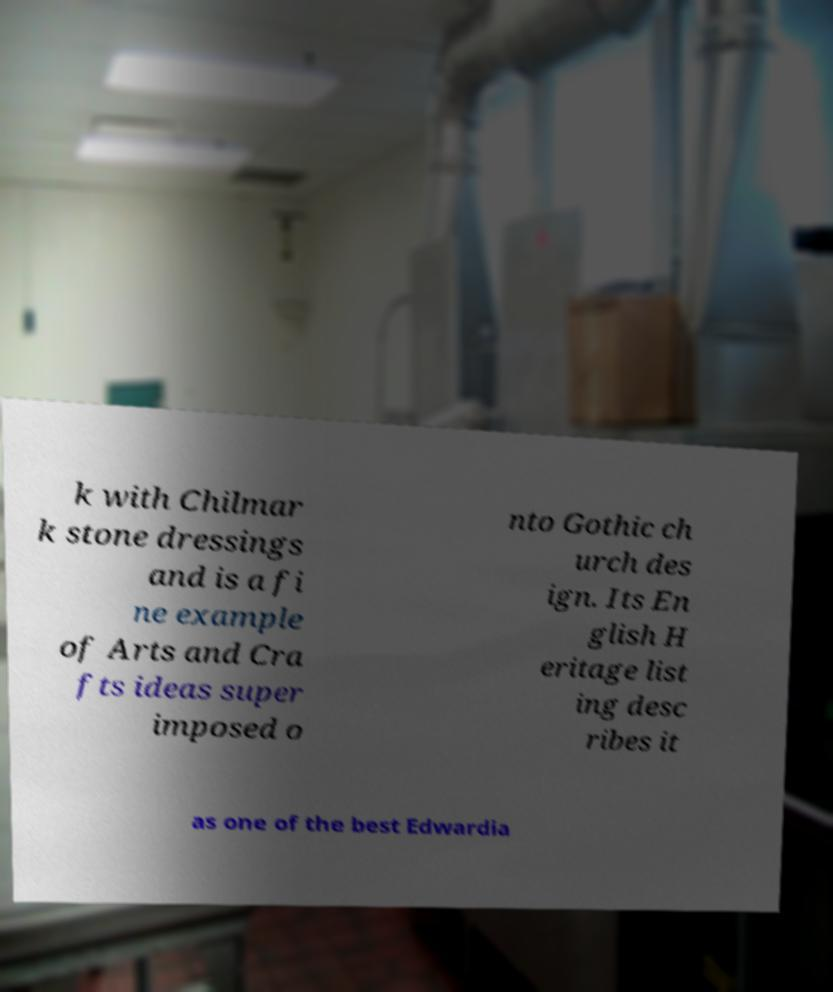Can you read and provide the text displayed in the image?This photo seems to have some interesting text. Can you extract and type it out for me? k with Chilmar k stone dressings and is a fi ne example of Arts and Cra fts ideas super imposed o nto Gothic ch urch des ign. Its En glish H eritage list ing desc ribes it as one of the best Edwardia 